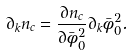<formula> <loc_0><loc_0><loc_500><loc_500>\partial _ { k } n _ { c } = \frac { \partial n _ { c } } { \partial \bar { \phi } _ { 0 } ^ { 2 } } \partial _ { k } \bar { \phi } _ { 0 } ^ { 2 } .</formula> 